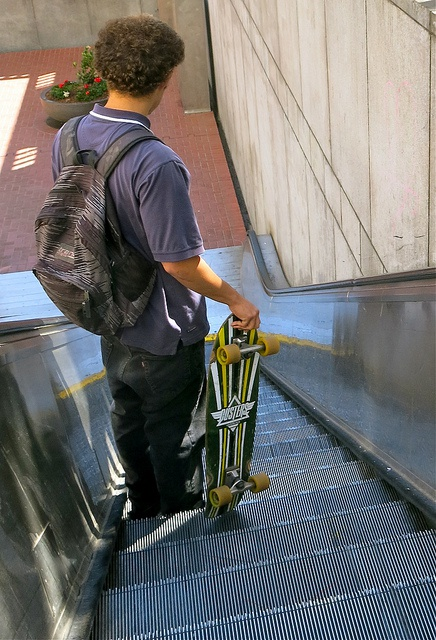Describe the objects in this image and their specific colors. I can see people in tan, black, gray, and maroon tones, backpack in tan, black, gray, and darkgray tones, skateboard in tan, black, olive, gray, and darkgray tones, and potted plant in tan, darkgreen, gray, and black tones in this image. 